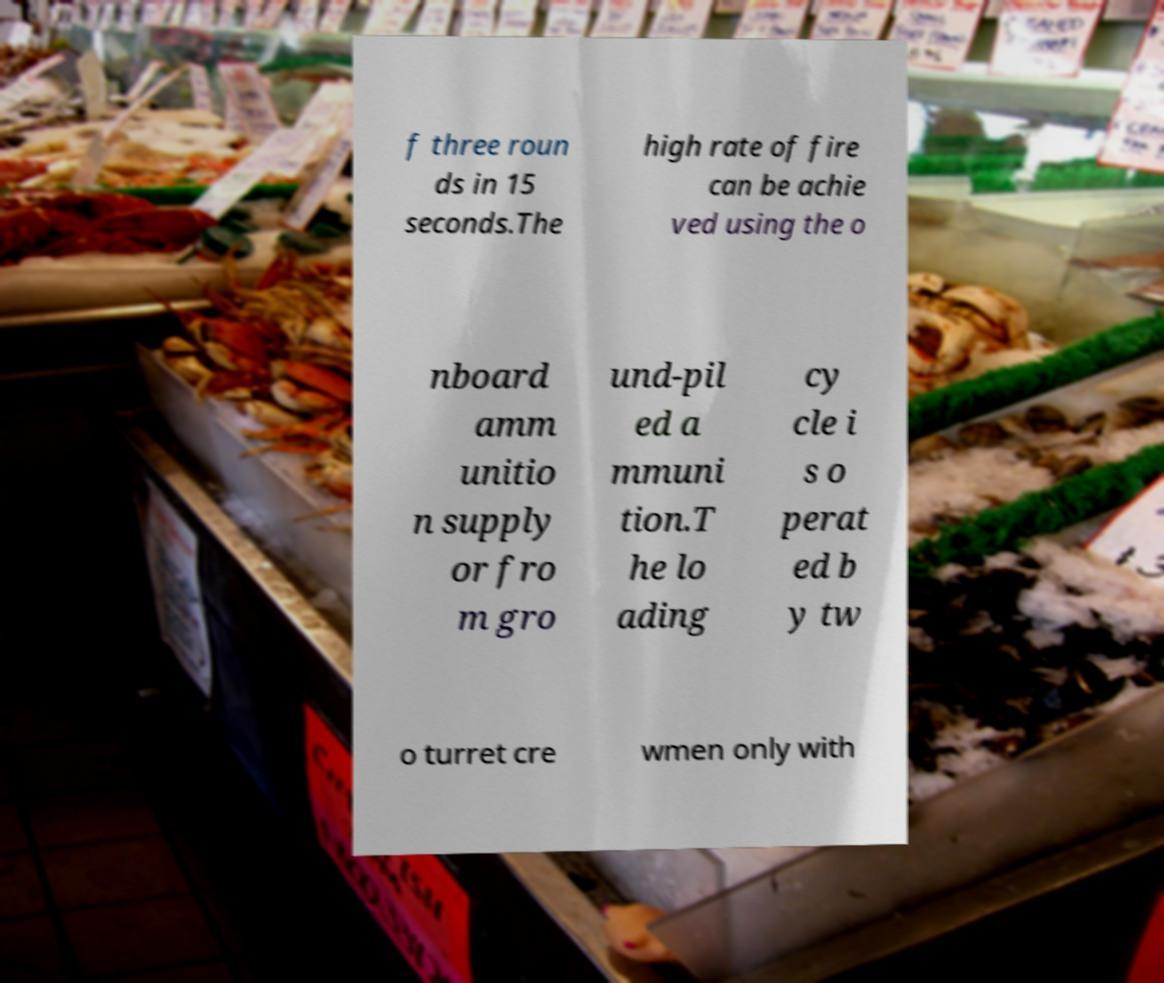Can you read and provide the text displayed in the image?This photo seems to have some interesting text. Can you extract and type it out for me? f three roun ds in 15 seconds.The high rate of fire can be achie ved using the o nboard amm unitio n supply or fro m gro und-pil ed a mmuni tion.T he lo ading cy cle i s o perat ed b y tw o turret cre wmen only with 